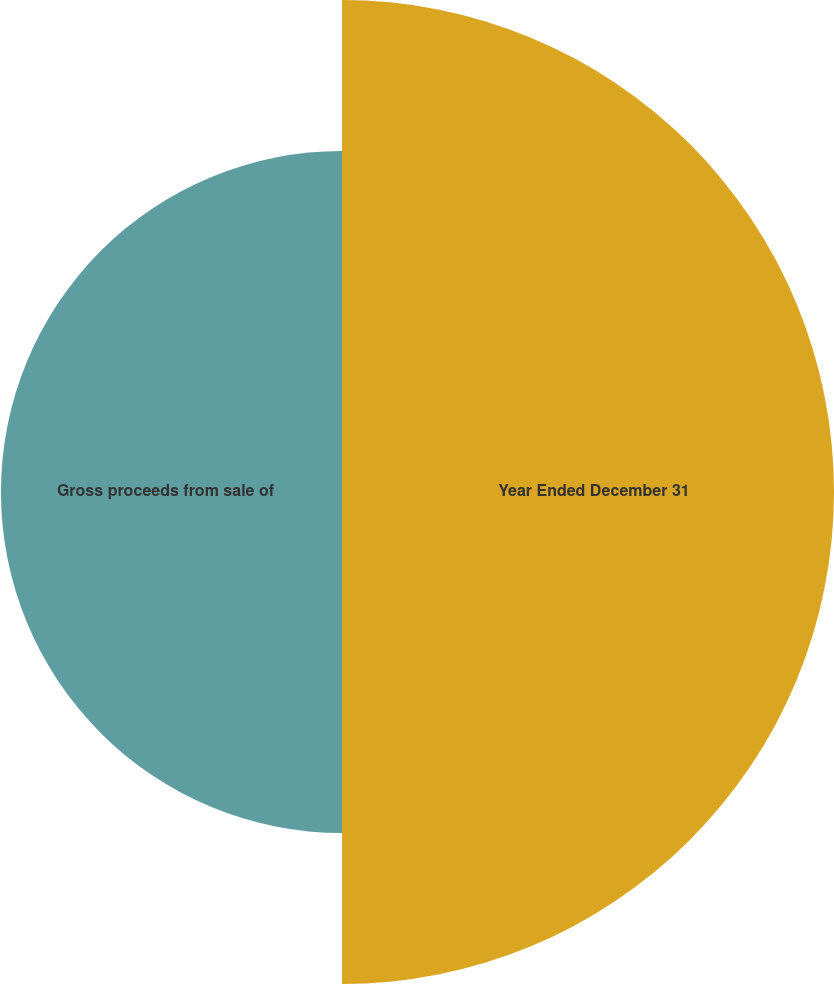Convert chart to OTSL. <chart><loc_0><loc_0><loc_500><loc_500><pie_chart><fcel>Year Ended December 31<fcel>Gross proceeds from sale of<nl><fcel>59.06%<fcel>40.94%<nl></chart> 